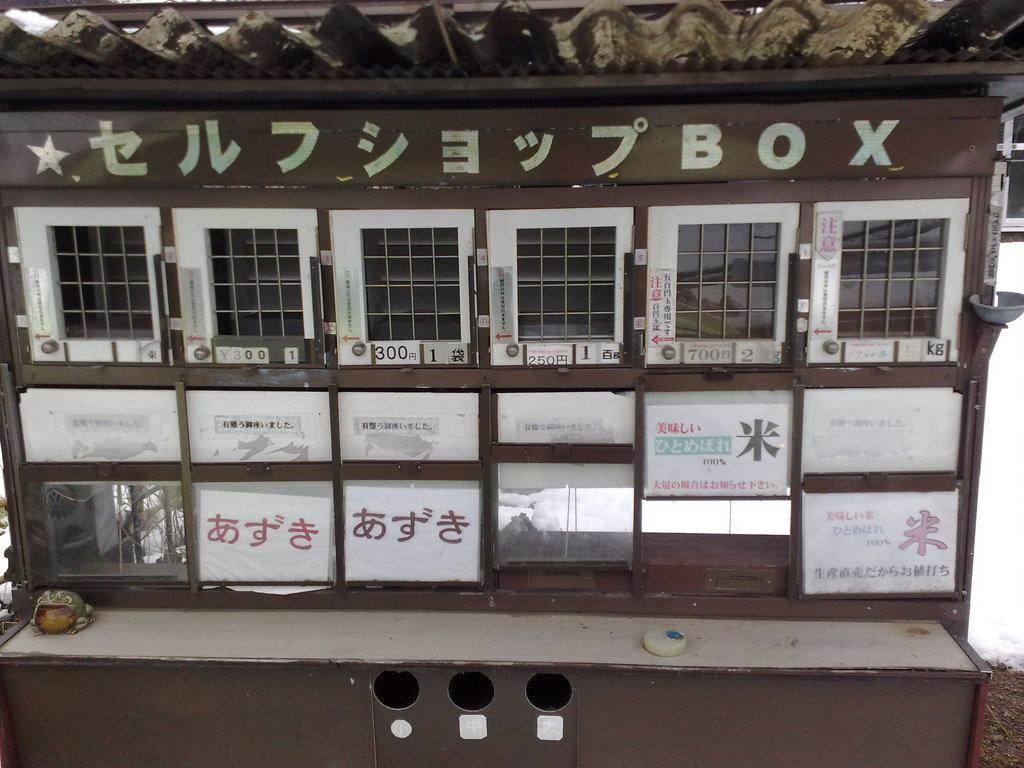<image>
Relay a brief, clear account of the picture shown. An old brown wooden box with one of the compartments labeled with the number 300 